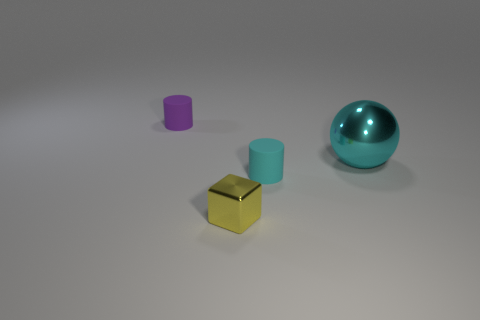Add 2 big cyan balls. How many objects exist? 6 Subtract all cyan cylinders. How many cylinders are left? 1 Add 3 small purple matte objects. How many small purple matte objects are left? 4 Add 1 matte cubes. How many matte cubes exist? 1 Subtract 0 blue cubes. How many objects are left? 4 Subtract all cubes. How many objects are left? 3 Subtract all brown cylinders. Subtract all red cubes. How many cylinders are left? 2 Subtract all yellow balls. How many purple cylinders are left? 1 Subtract all large yellow shiny blocks. Subtract all blocks. How many objects are left? 3 